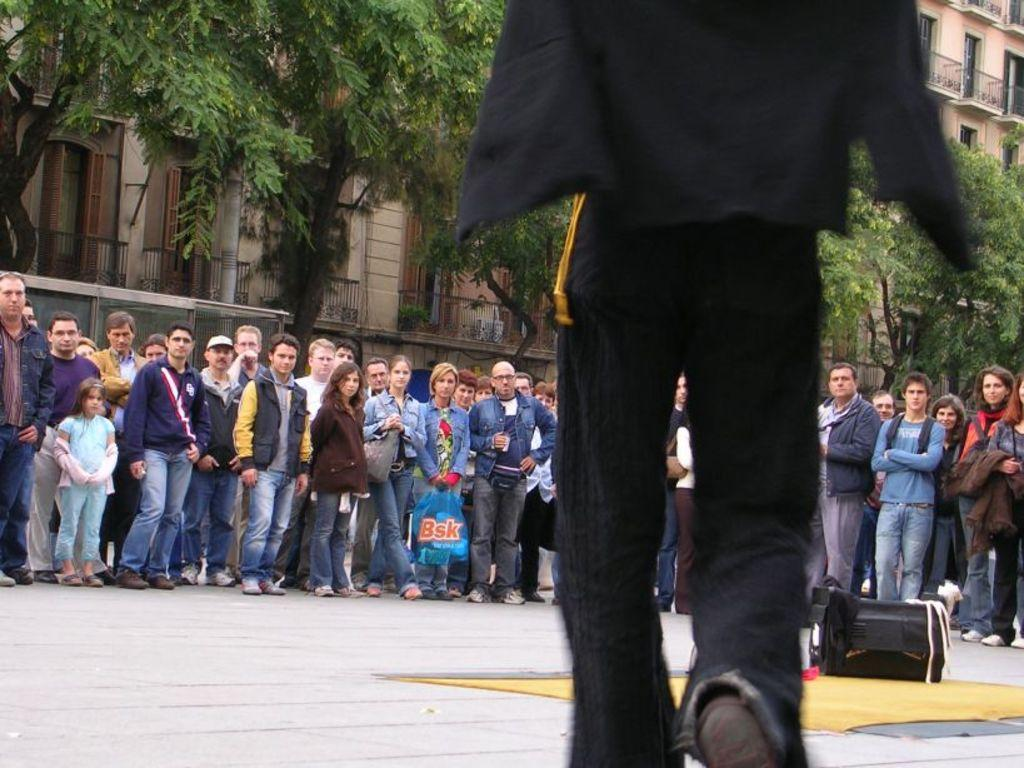What is the main object on the mat in the image? There is a speaker-like object on a mat in the image. Can you describe the people in the image? There are people in the image, but their specific actions or appearances are not mentioned in the facts. What type of structures can be seen in the image? There are buildings in the image. What type of vegetation is present in the image? There are trees in the image. What other unspecified objects can be seen in the image? There are other unspecified objects in the image, but their specific details are not mentioned in the facts. Where is the van parked in the image? There is no van present in the image. Can you describe the squirrel climbing the tree in the image? There is no squirrel climbing the tree in the image; only trees are mentioned. 